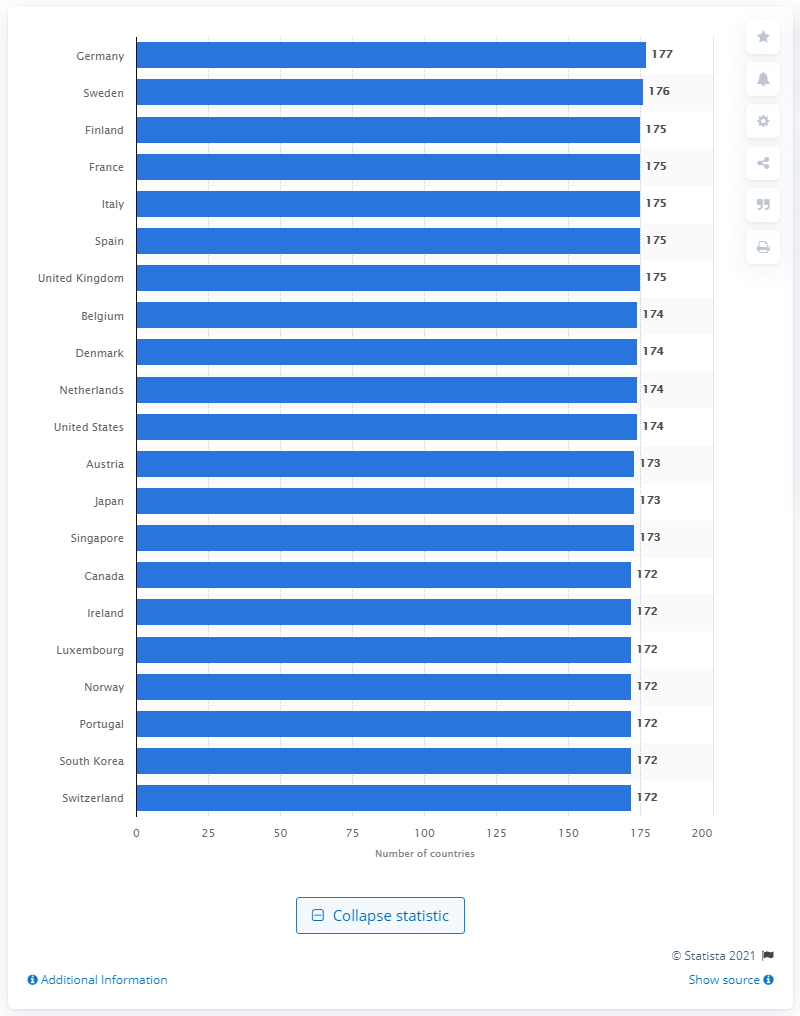Highlight a few significant elements in this photo. Germany passport holders can access 177 countries visa-free. 